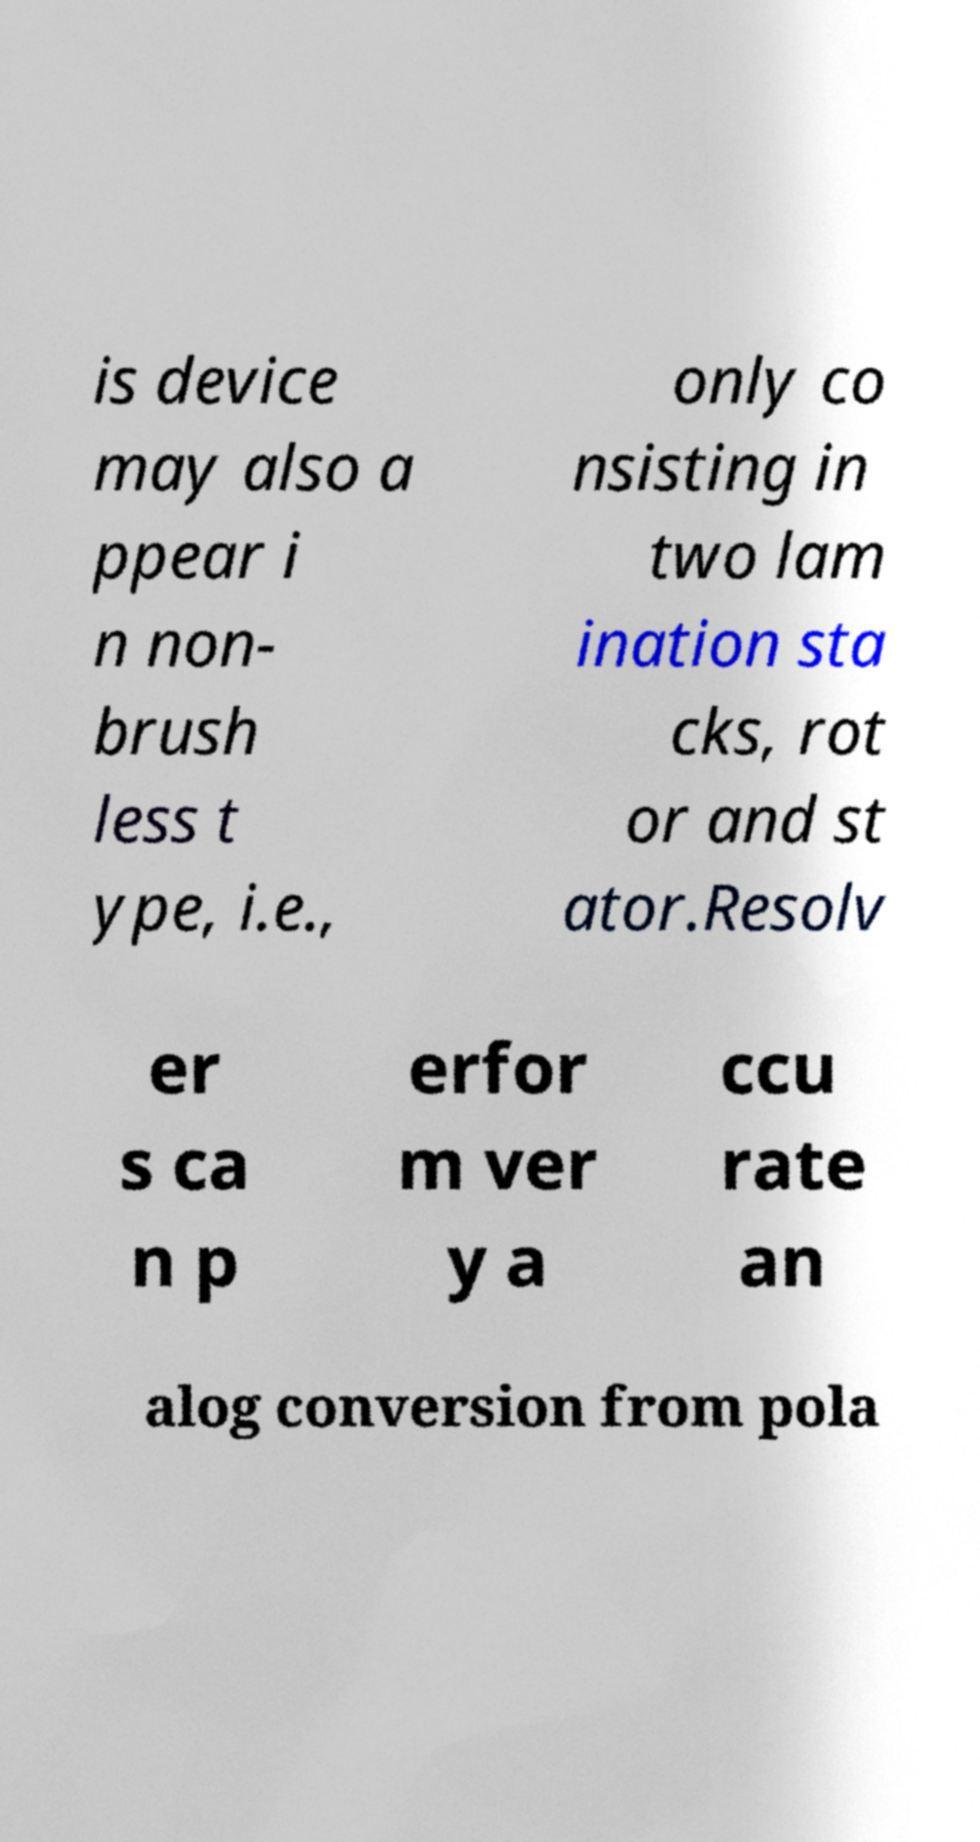Please read and relay the text visible in this image. What does it say? is device may also a ppear i n non- brush less t ype, i.e., only co nsisting in two lam ination sta cks, rot or and st ator.Resolv er s ca n p erfor m ver y a ccu rate an alog conversion from pola 